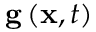Convert formula to latex. <formula><loc_0><loc_0><loc_500><loc_500>{ { g } \left ( { { x } , t } \right ) }</formula> 